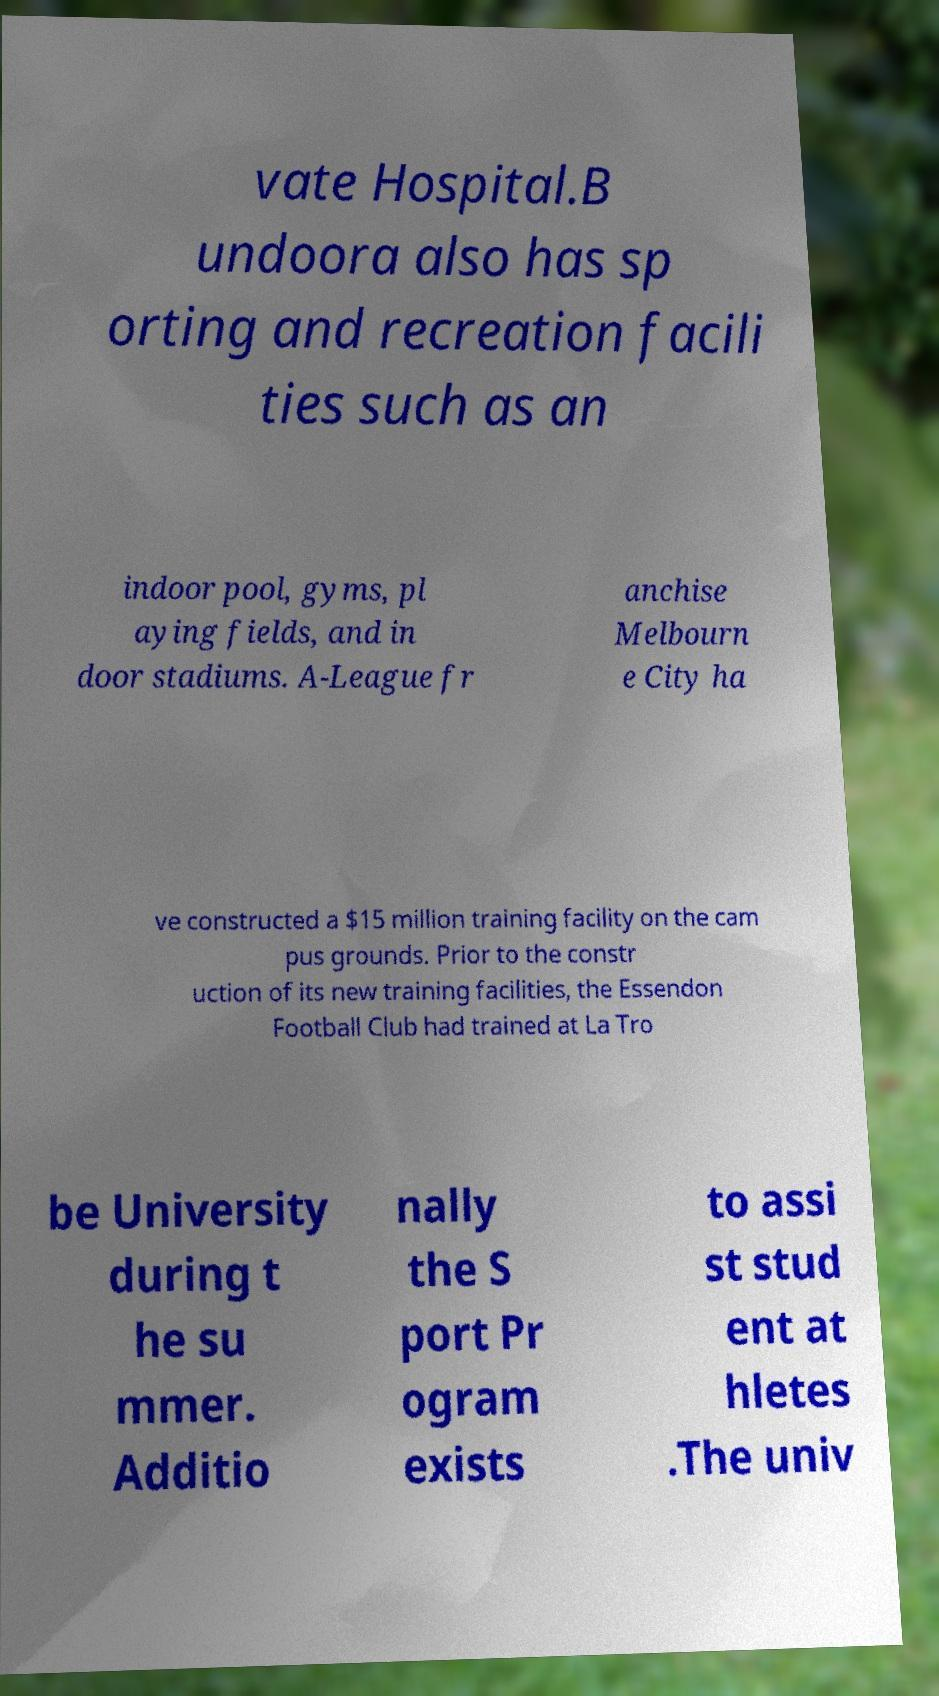Could you extract and type out the text from this image? vate Hospital.B undoora also has sp orting and recreation facili ties such as an indoor pool, gyms, pl aying fields, and in door stadiums. A-League fr anchise Melbourn e City ha ve constructed a $15 million training facility on the cam pus grounds. Prior to the constr uction of its new training facilities, the Essendon Football Club had trained at La Tro be University during t he su mmer. Additio nally the S port Pr ogram exists to assi st stud ent at hletes .The univ 